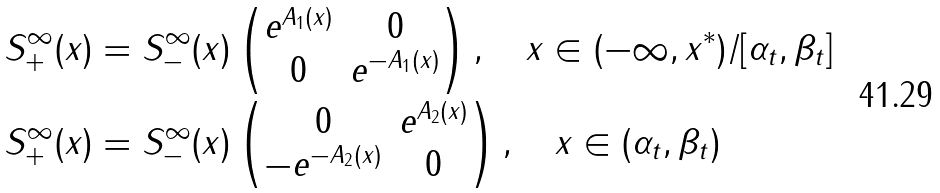<formula> <loc_0><loc_0><loc_500><loc_500>S ^ { \infty } _ { + } ( x ) & = S ^ { \infty } _ { - } ( x ) \begin{pmatrix} e ^ { A _ { 1 } ( x ) } & 0 \\ 0 & e ^ { - A _ { 1 } ( x ) } \end{pmatrix} , \quad x \in ( - \infty , x ^ { \ast } ) / [ \alpha _ { t } , \beta _ { t } ] \\ S ^ { \infty } _ { + } ( x ) & = S ^ { \infty } _ { - } ( x ) \begin{pmatrix} 0 & e ^ { A _ { 2 } ( x ) } \\ - e ^ { - A _ { 2 } ( x ) } & 0 \end{pmatrix} , \quad x \in ( \alpha _ { t } , \beta _ { t } )</formula> 